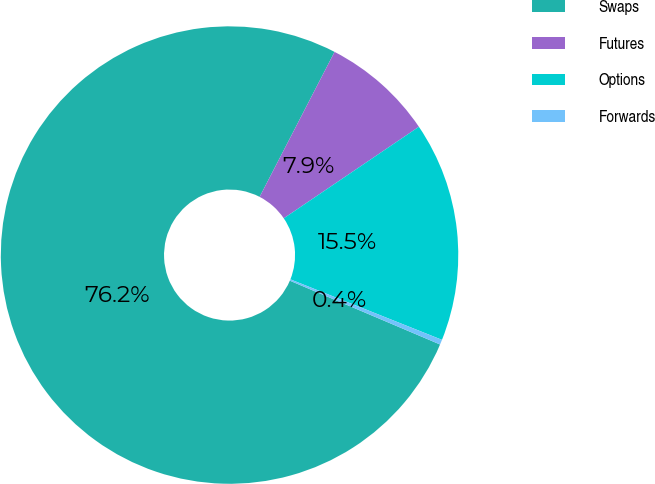Convert chart. <chart><loc_0><loc_0><loc_500><loc_500><pie_chart><fcel>Swaps<fcel>Futures<fcel>Options<fcel>Forwards<nl><fcel>76.2%<fcel>7.93%<fcel>15.52%<fcel>0.35%<nl></chart> 